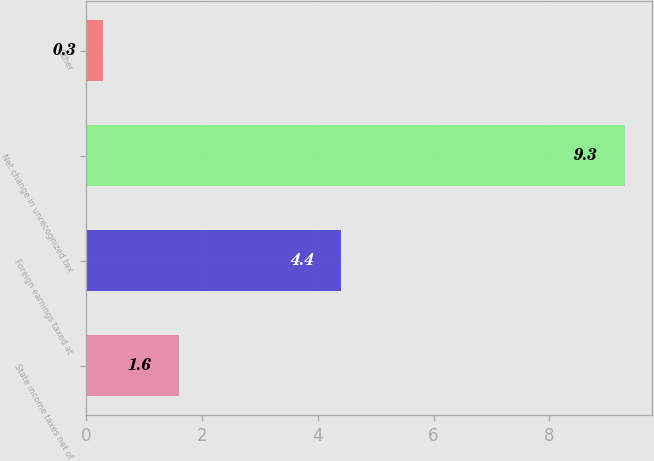Convert chart to OTSL. <chart><loc_0><loc_0><loc_500><loc_500><bar_chart><fcel>State income taxes net of<fcel>Foreign earnings taxed at<fcel>Net change in unrecognized tax<fcel>Other<nl><fcel>1.6<fcel>4.4<fcel>9.3<fcel>0.3<nl></chart> 